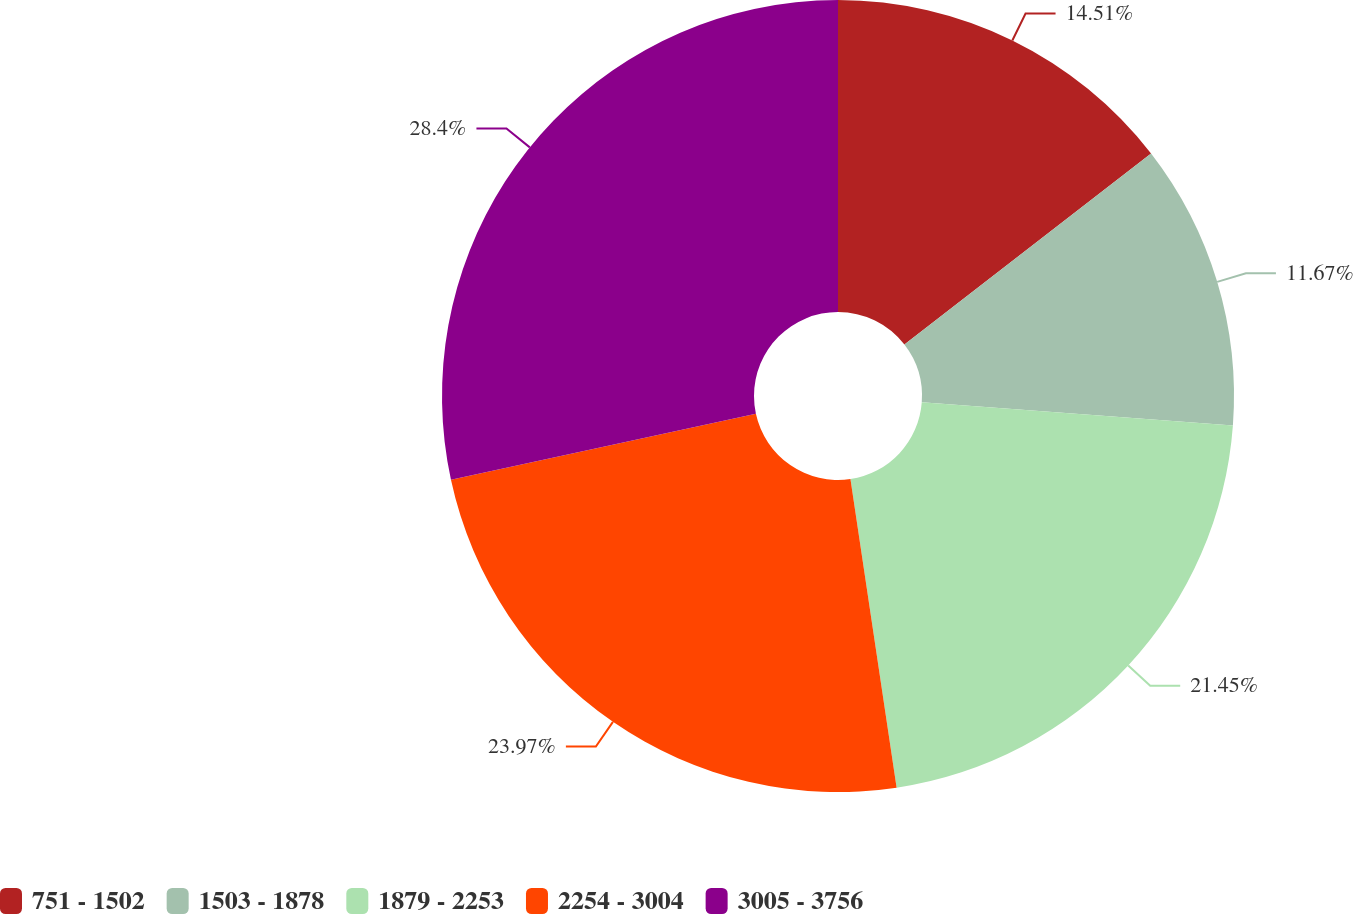Convert chart to OTSL. <chart><loc_0><loc_0><loc_500><loc_500><pie_chart><fcel>751 - 1502<fcel>1503 - 1878<fcel>1879 - 2253<fcel>2254 - 3004<fcel>3005 - 3756<nl><fcel>14.51%<fcel>11.67%<fcel>21.45%<fcel>23.97%<fcel>28.39%<nl></chart> 